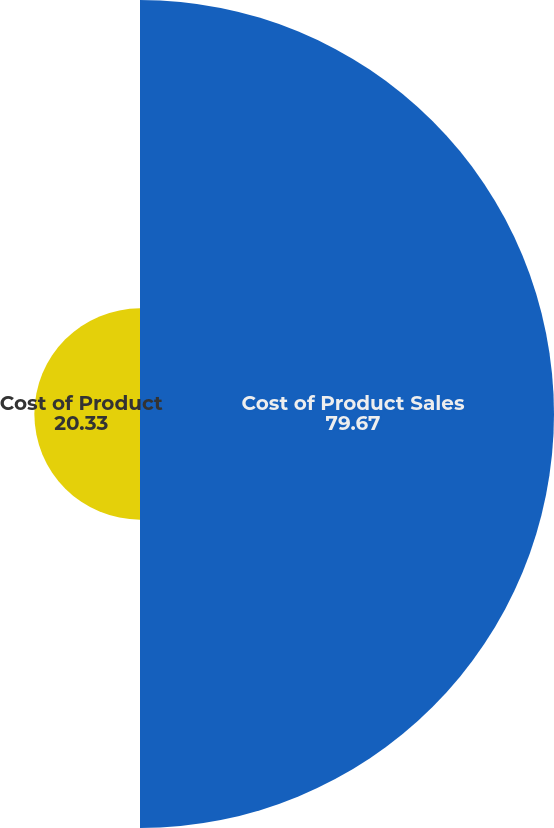Convert chart to OTSL. <chart><loc_0><loc_0><loc_500><loc_500><pie_chart><fcel>Cost of Product Sales<fcel>Cost of Product<nl><fcel>79.67%<fcel>20.33%<nl></chart> 